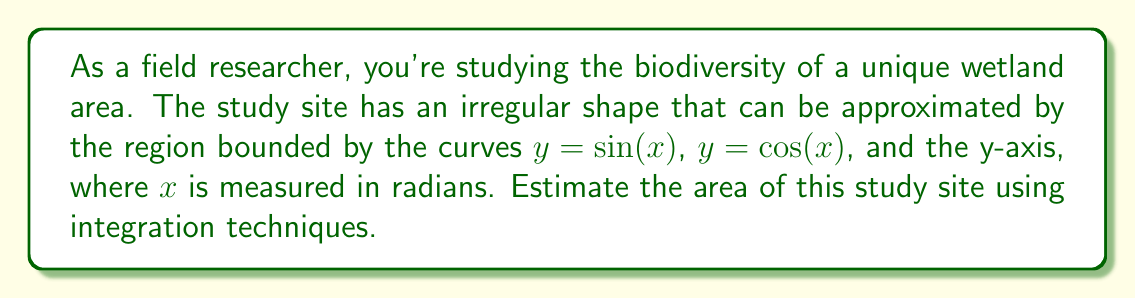Could you help me with this problem? To estimate the area of this irregularly shaped study site, we'll use definite integrals. Let's approach this step-by-step:

1) First, we need to determine the bounds of integration. The region is bounded by $y = \sin(x)$, $y = \cos(x)$, and the y-axis (x = 0).

2) To find the upper bound, we need to find where $\sin(x) = \cos(x)$:
   $\sin(x) = \cos(x)$
   $\tan(x) = 1$
   $x = \frac{\pi}{4}$

3) So, our bounds of integration are from $x = 0$ to $x = \frac{\pi}{4}$.

4) The area will be the integral of the difference between the upper curve ($\cos(x)$) and the lower curve ($\sin(x)$):

   $$\text{Area} = \int_0^{\frac{\pi}{4}} [\cos(x) - \sin(x)] dx$$

5) To solve this integral:
   $$\begin{align}
   \int_0^{\frac{\pi}{4}} [\cos(x) - \sin(x)] dx &= [\sin(x) + \cos(x)]_0^{\frac{\pi}{4}} \\
   &= [\sin(\frac{\pi}{4}) + \cos(\frac{\pi}{4})] - [\sin(0) + \cos(0)] \\
   &= [\frac{\sqrt{2}}{2} + \frac{\sqrt{2}}{2}] - [0 + 1] \\
   &= \sqrt{2} - 1
   \end{align}$$

6) Therefore, the estimated area of the study site is $\sqrt{2} - 1$ square radians.

7) If we need this in square meters, we'd need to know the scale of our x and y axes in meters per radian.
Answer: $\sqrt{2} - 1$ square radians 